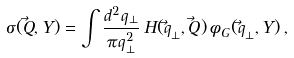<formula> <loc_0><loc_0><loc_500><loc_500>\sigma ( \vec { Q } , Y ) = \int \frac { d ^ { 2 } q _ { \bot } } { \pi q ^ { 2 } _ { \bot } } \, H ( \vec { q } _ { \bot } , \vec { Q } ) \, \phi _ { G } ( \vec { q } _ { \bot } , Y ) \, ,</formula> 